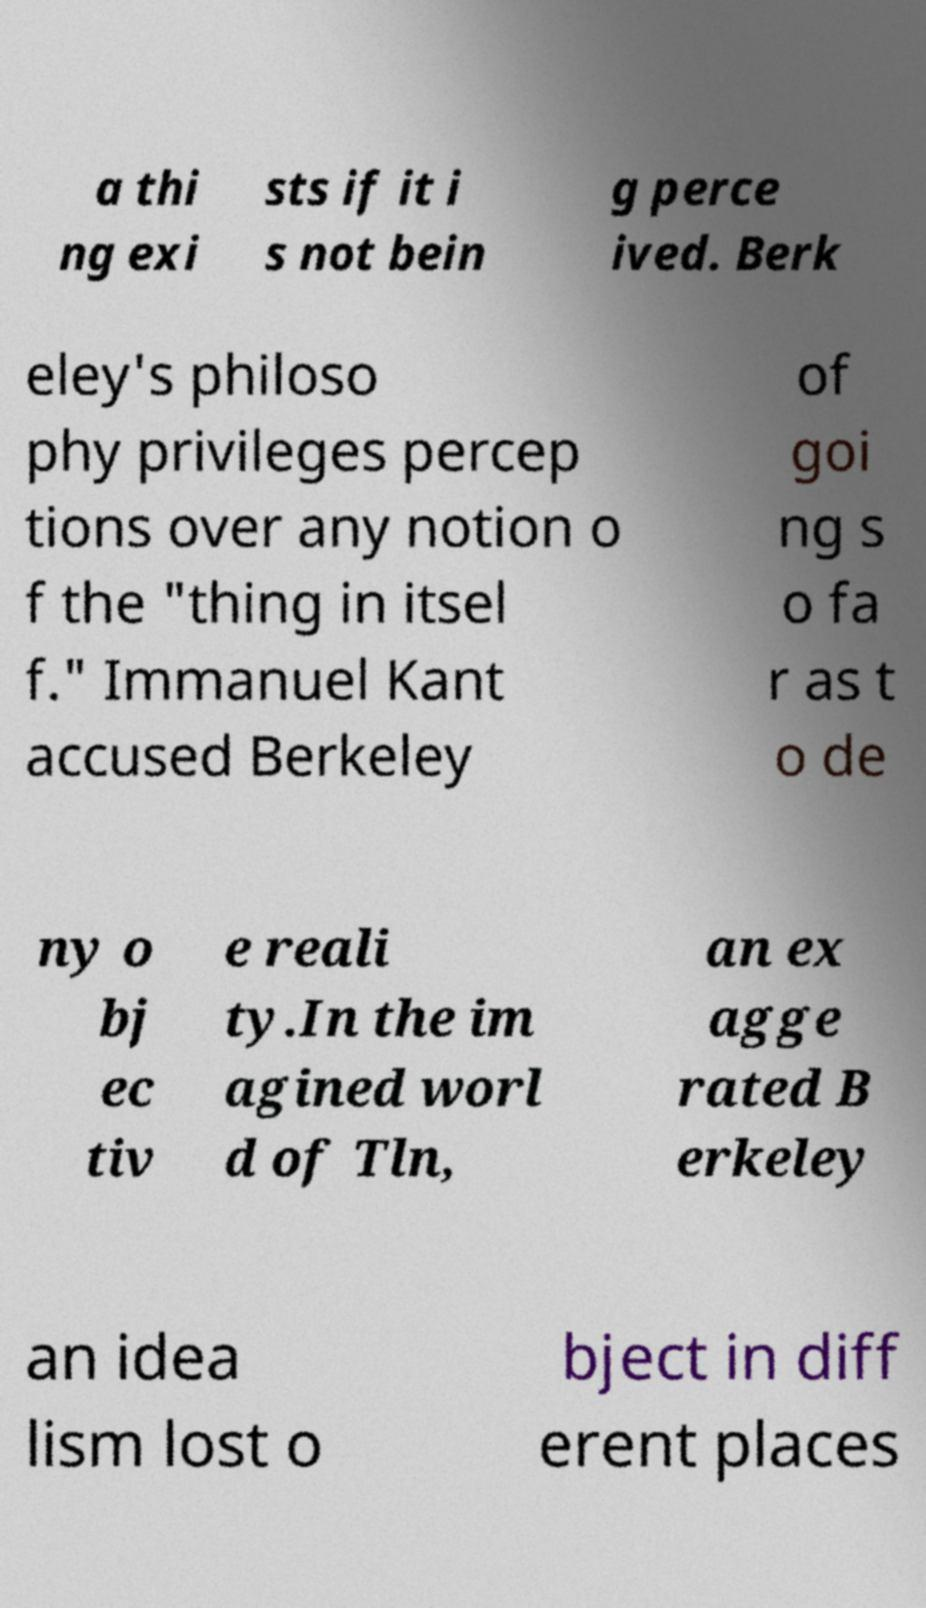Can you read and provide the text displayed in the image?This photo seems to have some interesting text. Can you extract and type it out for me? a thi ng exi sts if it i s not bein g perce ived. Berk eley's philoso phy privileges percep tions over any notion o f the "thing in itsel f." Immanuel Kant accused Berkeley of goi ng s o fa r as t o de ny o bj ec tiv e reali ty.In the im agined worl d of Tln, an ex agge rated B erkeley an idea lism lost o bject in diff erent places 